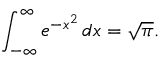Convert formula to latex. <formula><loc_0><loc_0><loc_500><loc_500>\int _ { - \infty } ^ { \infty } e ^ { - x ^ { 2 } } \, d x = { \sqrt { \pi } } .</formula> 